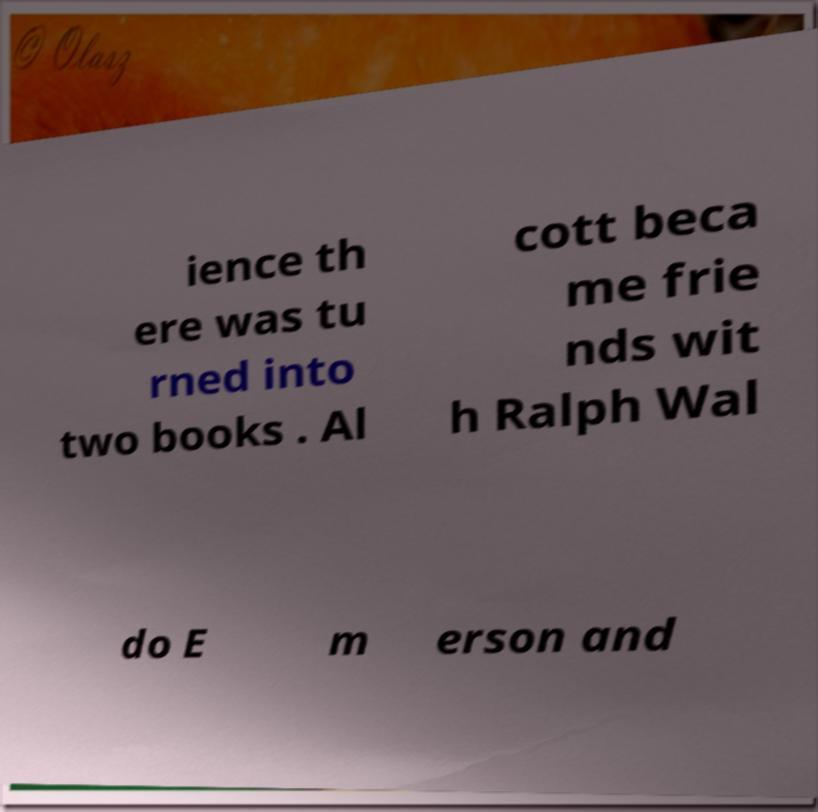Please identify and transcribe the text found in this image. ience th ere was tu rned into two books . Al cott beca me frie nds wit h Ralph Wal do E m erson and 